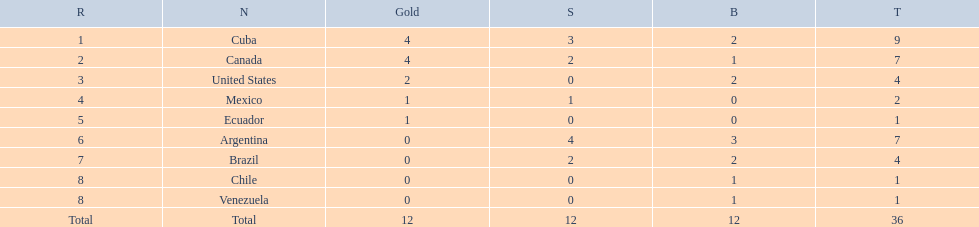Which nations competed in the 2011 pan american games? Cuba, Canada, United States, Mexico, Ecuador, Argentina, Brazil, Chile, Venezuela. Of these nations which ones won gold? Cuba, Canada, United States, Mexico, Ecuador. Which nation of the ones that won gold did not win silver? United States. 